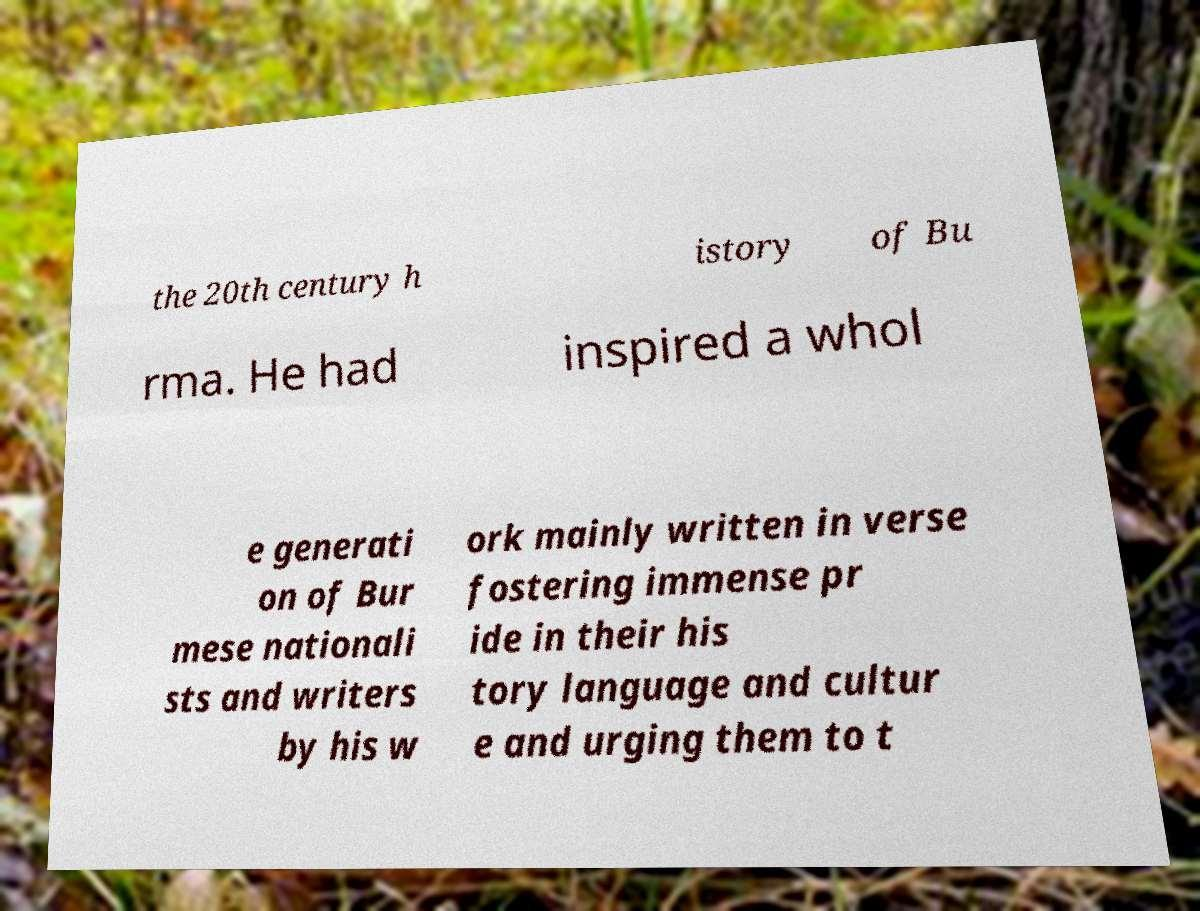Can you accurately transcribe the text from the provided image for me? the 20th century h istory of Bu rma. He had inspired a whol e generati on of Bur mese nationali sts and writers by his w ork mainly written in verse fostering immense pr ide in their his tory language and cultur e and urging them to t 